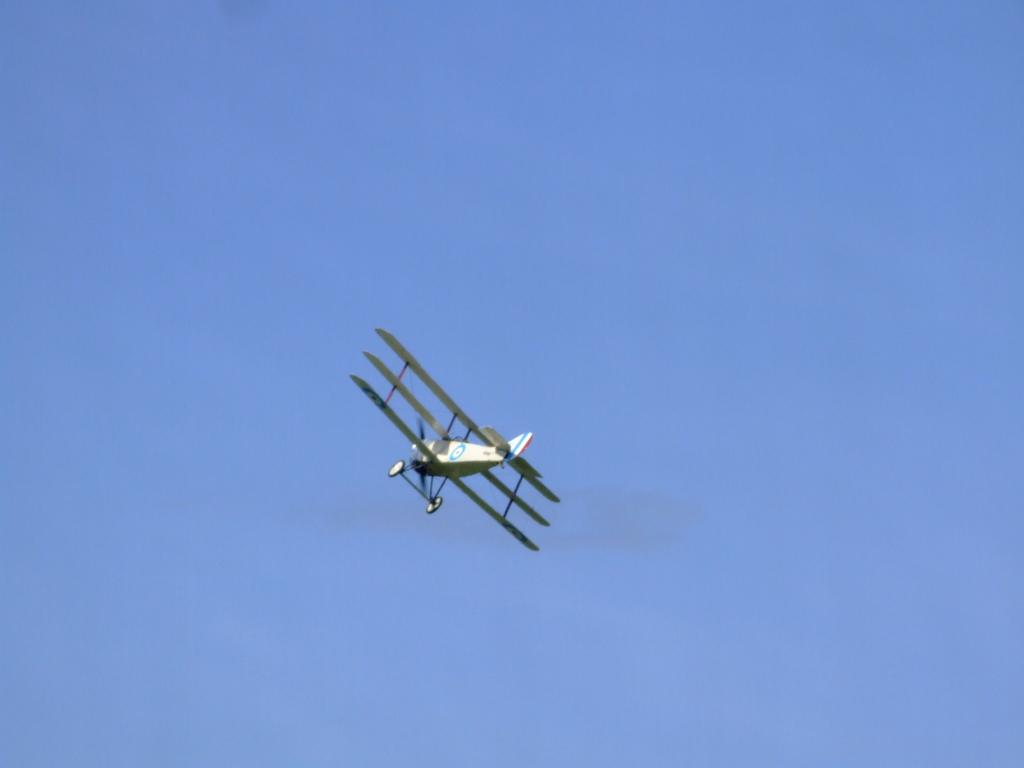What is the main subject of the picture? The main subject of the picture is an aircraft. What is the aircraft doing in the picture? The aircraft is flying in the picture. What can be seen in the background of the image? The sky is visible in the picture. What type of animal can be seen playing a musical instrument in the image? There is no animal or musical instrument present in the image; it features an aircraft flying in the sky. 